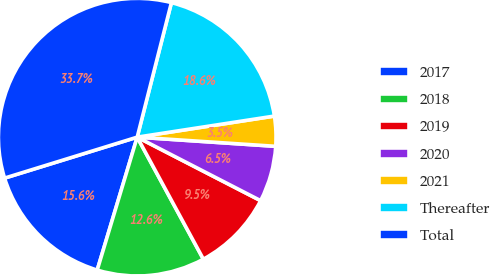Convert chart to OTSL. <chart><loc_0><loc_0><loc_500><loc_500><pie_chart><fcel>2017<fcel>2018<fcel>2019<fcel>2020<fcel>2021<fcel>Thereafter<fcel>Total<nl><fcel>15.58%<fcel>12.56%<fcel>9.53%<fcel>6.51%<fcel>3.48%<fcel>18.61%<fcel>33.73%<nl></chart> 